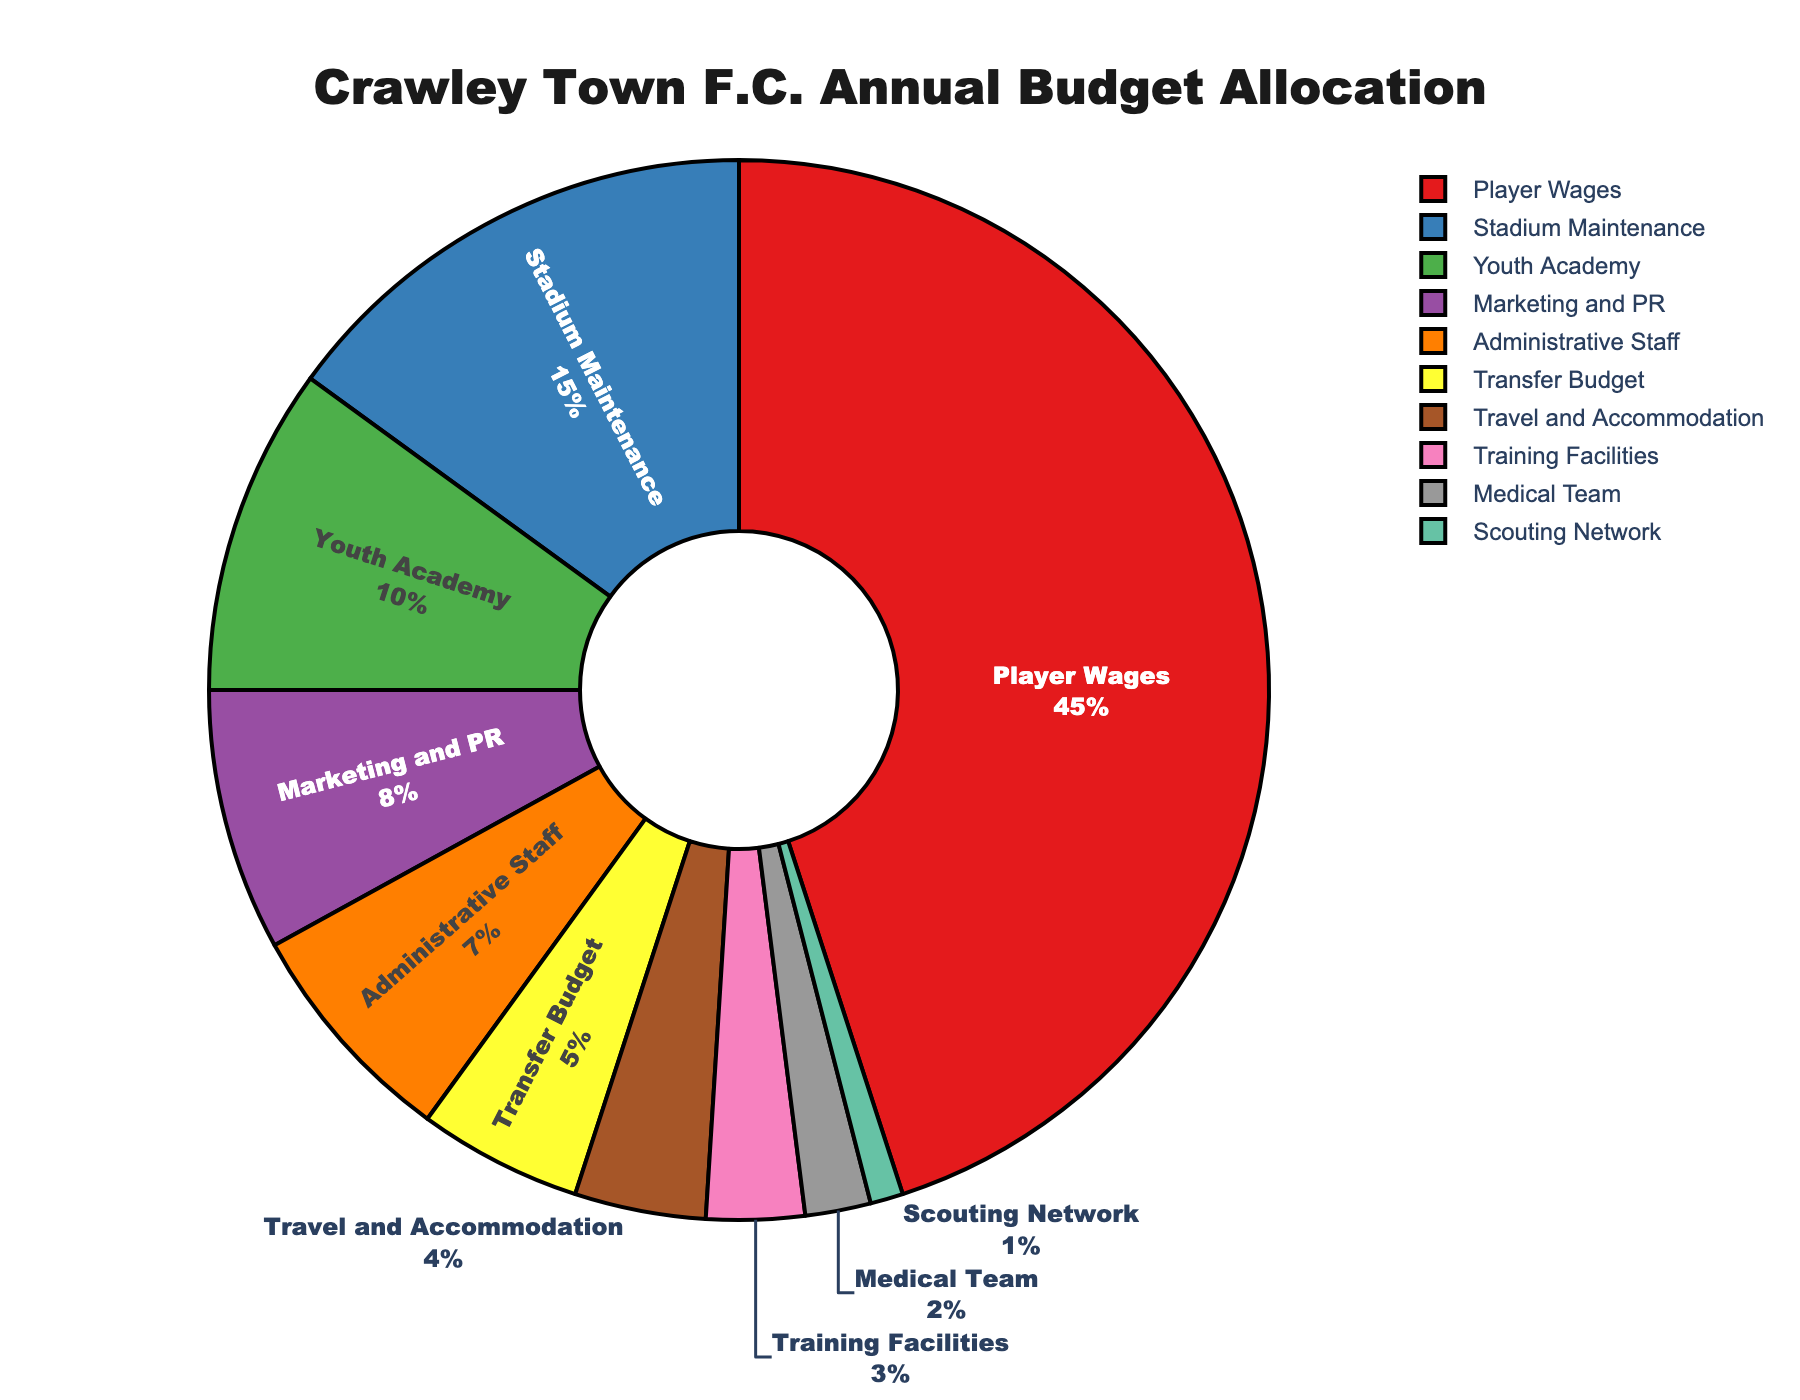What is the largest single allocation in Crawley Town F.C.'s annual budget? By visually inspecting the pie chart, the largest segment is "Player Wages", which is clearly the biggest portion of the chart.
Answer: Player Wages How much more is allocated to Player Wages compared to Youth Academy? The allocation for Player Wages is 45%, and for Youth Academy, it is 10%. The difference is 45% - 10% = 35%.
Answer: 35% Which department receives the smallest portion of the budget? The smallest segment in the pie chart represents the "Scouting Network", indicated with a small slice.
Answer: Scouting Network Of the funds allocated to Marketing and PR and Administrative Staff, which receives more and by how much? The Marketing and PR budget is 8%, and the Administrative Staff budget is 7%. By subtracting, 8% - 7% = 1%. Therefore, Marketing and PR receives 1% more than Administrative Staff.
Answer: Marketing and PR by 1% What percentage of the budget is dedicated to Training Facilities? By looking at the pie chart, the Training Facilities segment is 3%.
Answer: 3% What is the combined budget allocation for Player Wages, Stadium Maintenance, and Youth Academy? Adding the three relevant sections: 45% (Player Wages) + 15% (Stadium Maintenance) + 10% (Youth Academy) = 70%.
Answer: 70% How does the budget allocation for the Medical Team compare to the Scouting Network? The Medical Team has a budget allocation of 2%, while the Scouting Network has 1%. Comparing these, the Medical Team allocation is twice that of the Scouting Network.
Answer: Medical Team has twice the budget of Scouting Network What departments receive less than 5% of the budget each? Upon observation, please note the slices for Travel and Accommodation (4%), Training Facilities (3%), Medical Team (2%), and Scouting Network (1%).
Answer: Travel and Accommodation, Training Facilities, Medical Team, Scouting Network How much of the budget is allocated to the Transfer Budget, and what is its visual representation in the pie chart? The Transfer Budget allocation is represented by a distinct slice of 5%. By checking the pie chart, the segment labeled "Transfer Budget" is 5%.
Answer: 5% What is the total allocation percentage for Travel and Accommodation, Training Facilities, and Medical Team combined? Adding together those segments: 4% (Travel and Accommodation) + 3% (Training Facilities) + 2% (Medical Team) = 9%.
Answer: 9% 